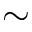Convert formula to latex. <formula><loc_0><loc_0><loc_500><loc_500>\sim</formula> 